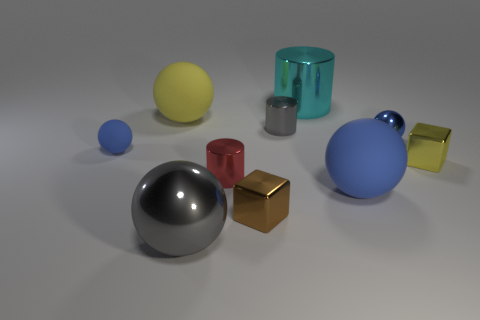Subtract all red cylinders. How many cylinders are left? 2 Subtract all cubes. How many objects are left? 8 Subtract all yellow cylinders. Subtract all purple cubes. How many cylinders are left? 3 Subtract all purple balls. How many cyan cylinders are left? 1 Subtract all cyan cylinders. Subtract all yellow rubber spheres. How many objects are left? 8 Add 6 red metal things. How many red metal things are left? 7 Add 1 tiny yellow metallic blocks. How many tiny yellow metallic blocks exist? 2 Subtract all gray cylinders. How many cylinders are left? 2 Subtract 0 cyan balls. How many objects are left? 10 Subtract 3 balls. How many balls are left? 2 